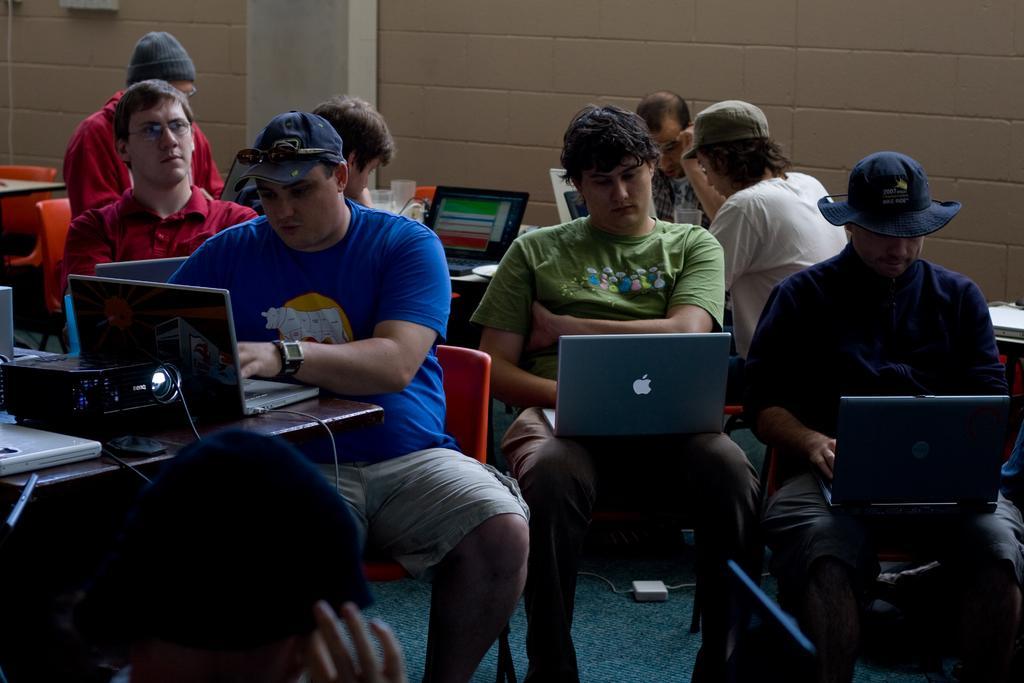In one or two sentences, can you explain what this image depicts? In this picture there is a man who is wearing cap, goggle, t-shirt, watch and short. He is sitting on the red chair and working on the laptop. On the table I can see the laptops, cables, projector machine and other objects. Behind him there is another man who is wearing spectacles and red shirt. He is sitting on the chair. In the top left corner I can see the man who is wearing cap, spectacle and red hoodie. He is sitting on the chair near to the table. On the table I can see the laptop, water glass and other objects. In front of him I can see another man who is looking in the laptop. In the center there is a man who is wearing green t-shirt and trouser. He is also working in the laptop, besides him there is a man who is wearing hat, shirt, trouser and he is sitting on the black chair. He is working on the laptop. Behind him there is a man who is wearing cap, white t-shirt and he is a sitting near to the wall. Beside him there is another man who is wearing spectacle, watch and shirt. He is sitting on the white chair. At the bottom I can see the cable on the green carpet. In the bottom left corner I can see another man. In the top left corner there is a white object which is placed on the wall near to the pillar. 